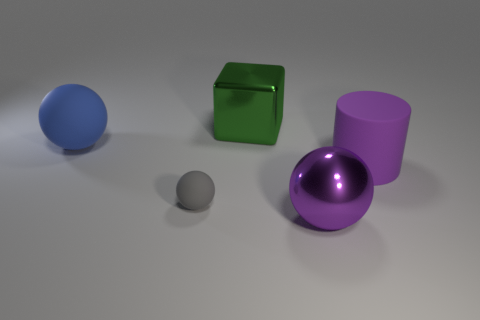Does the purple shiny sphere have the same size as the matte thing that is behind the purple matte thing?
Make the answer very short. Yes. Are there any other things that have the same shape as the large purple rubber thing?
Ensure brevity in your answer.  No. The gray matte object has what size?
Your answer should be compact. Small. Are there fewer tiny balls that are behind the small gray thing than gray shiny blocks?
Provide a succinct answer. No. Do the rubber cylinder and the blue thing have the same size?
Offer a terse response. Yes. Is there anything else that has the same size as the cylinder?
Offer a terse response. Yes. What color is the other ball that is made of the same material as the blue ball?
Offer a very short reply. Gray. Are there fewer metal things in front of the big purple matte thing than tiny matte spheres that are on the left side of the large blue rubber object?
Keep it short and to the point. No. What number of cylinders are the same color as the metallic sphere?
Your answer should be compact. 1. There is a big thing that is the same color as the metal ball; what is its material?
Keep it short and to the point. Rubber. 